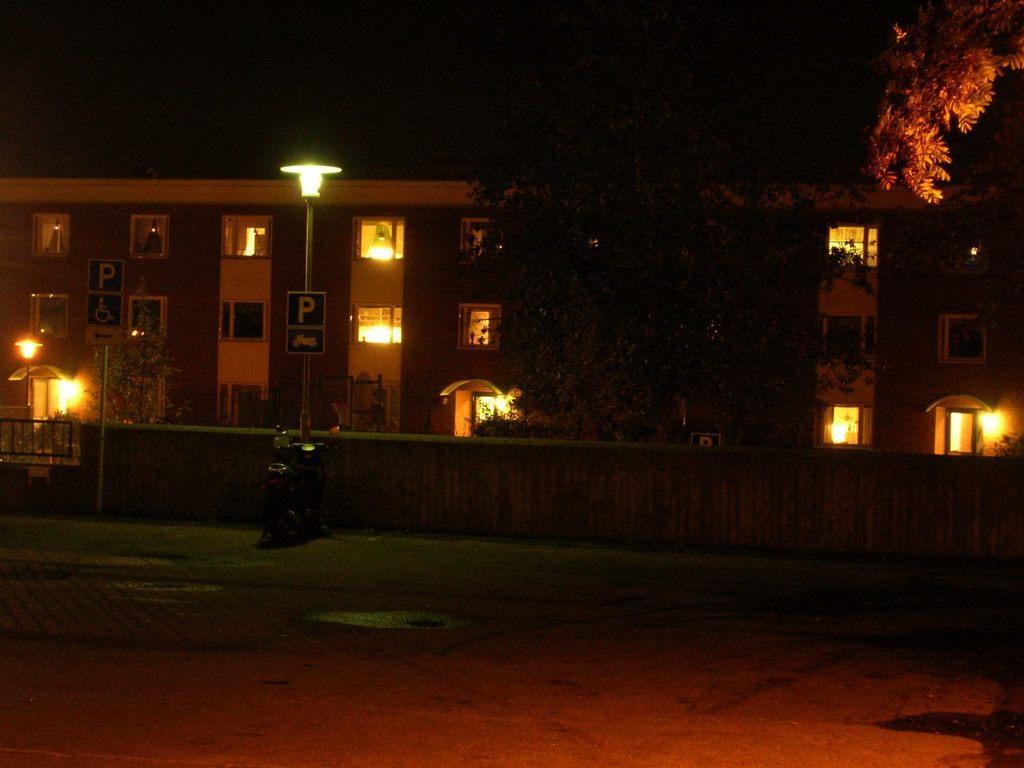Describe this image in one or two sentences. In this image I can see the ground, some water on the ground, few poles, few boards to the poles, few lights, a wall, few trees and a building. I can see few windows of the building. In the background I can see the dark sky. 